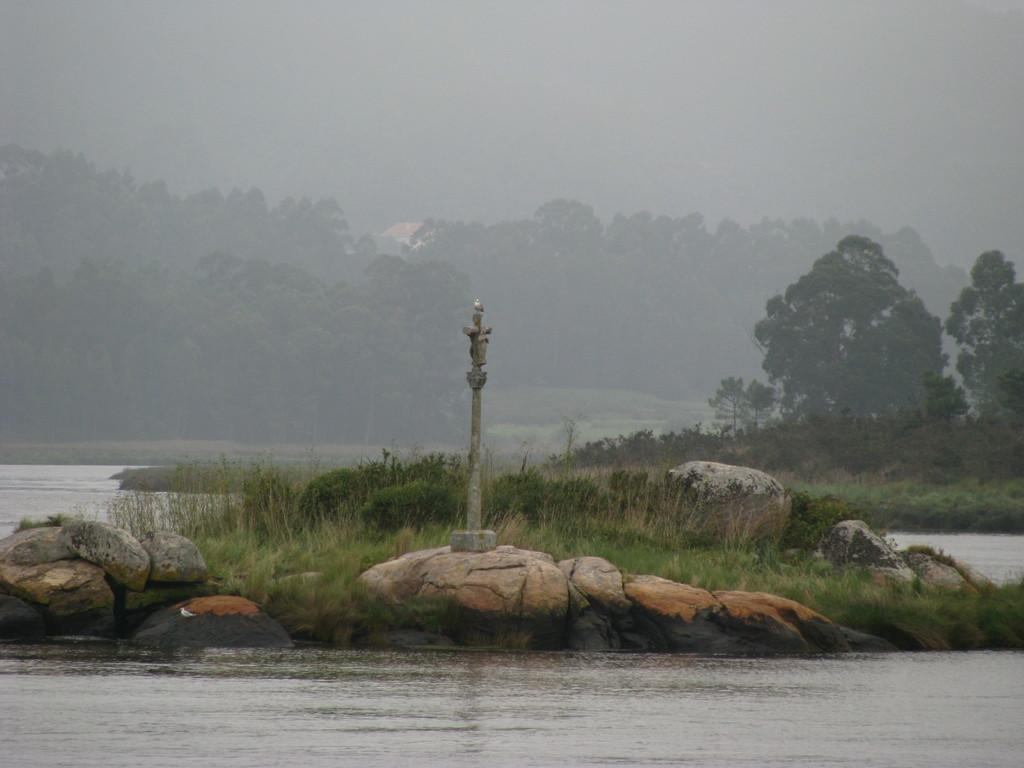What is visible in the image? Water is visible in the image. What can be seen in the background of the image? There are trees, plants, and grass visible in the background of the image. What type of material is the water made of in the image? The water in the image is not made of any material; it is a natural body of water. What type of copper object can be seen folded in the image? There is no copper object present in the image, and therefore no such activity can be observed. 